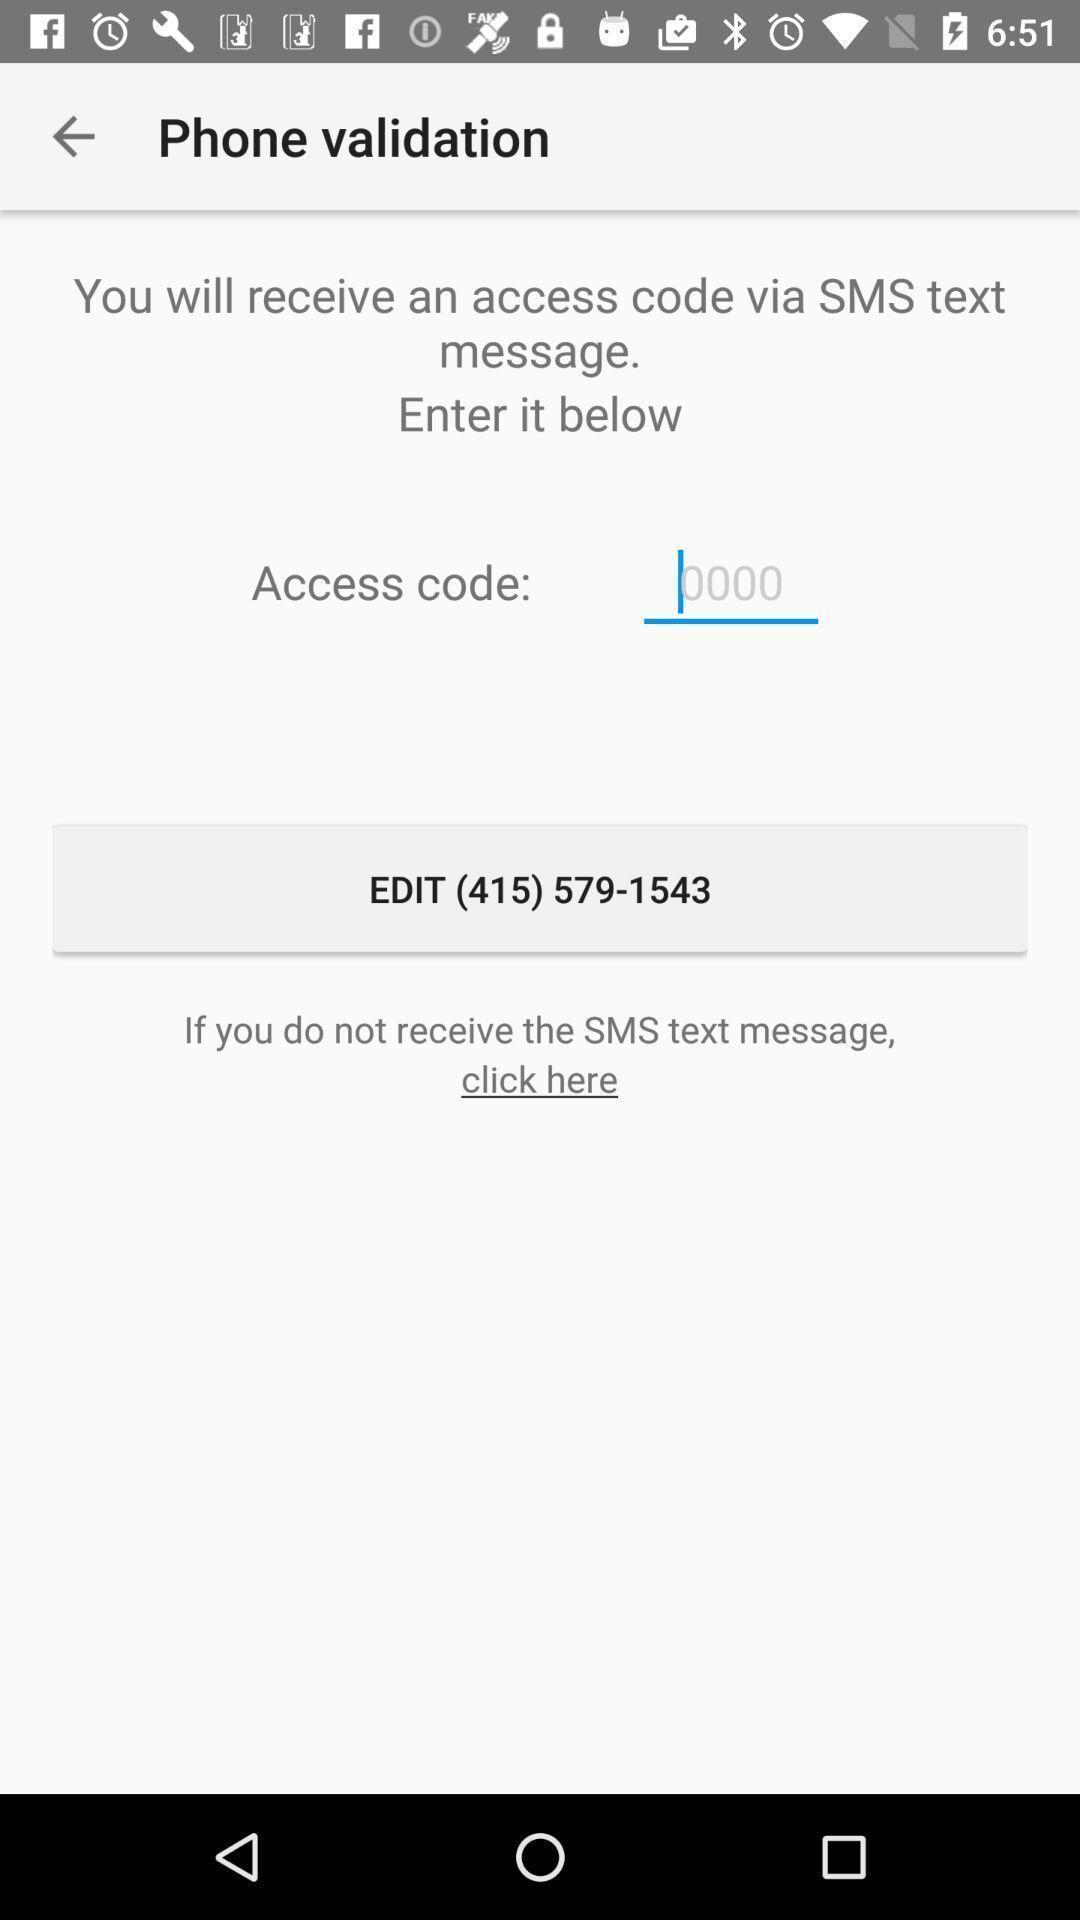Explain the elements present in this screenshot. Page displaying the phone validation. 